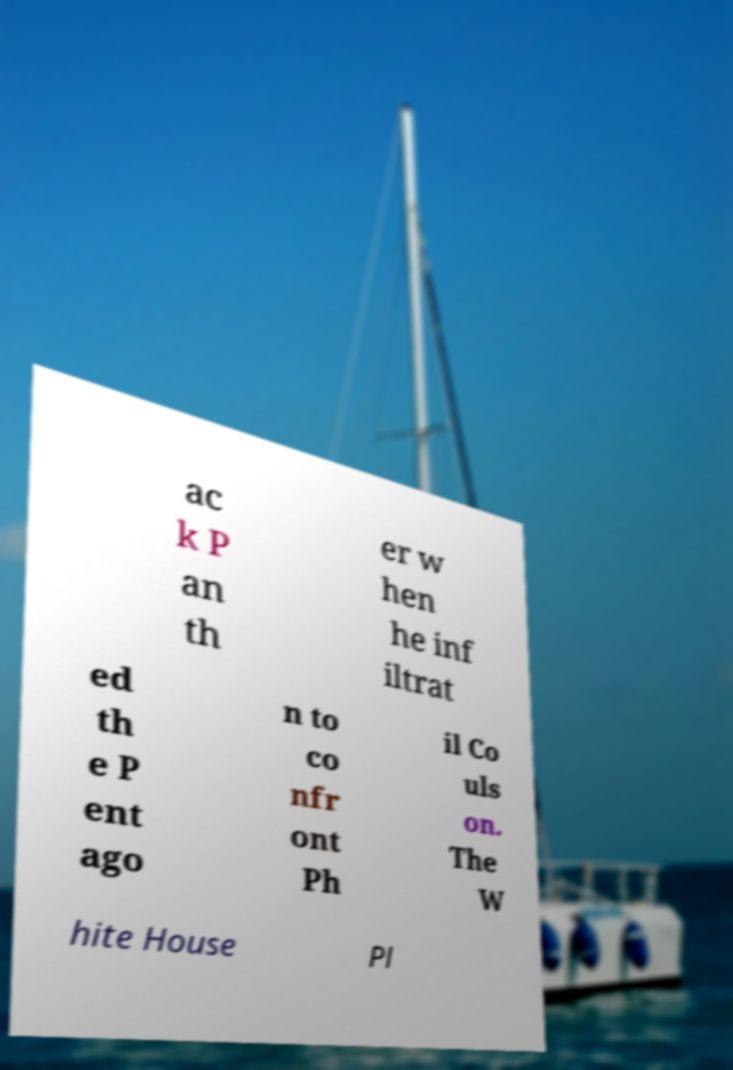Please read and relay the text visible in this image. What does it say? ac k P an th er w hen he inf iltrat ed th e P ent ago n to co nfr ont Ph il Co uls on. The W hite House Pl 